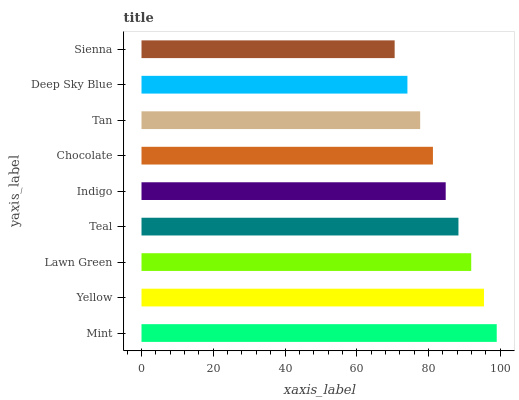Is Sienna the minimum?
Answer yes or no. Yes. Is Mint the maximum?
Answer yes or no. Yes. Is Yellow the minimum?
Answer yes or no. No. Is Yellow the maximum?
Answer yes or no. No. Is Mint greater than Yellow?
Answer yes or no. Yes. Is Yellow less than Mint?
Answer yes or no. Yes. Is Yellow greater than Mint?
Answer yes or no. No. Is Mint less than Yellow?
Answer yes or no. No. Is Indigo the high median?
Answer yes or no. Yes. Is Indigo the low median?
Answer yes or no. Yes. Is Chocolate the high median?
Answer yes or no. No. Is Mint the low median?
Answer yes or no. No. 